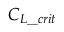Convert formula to latex. <formula><loc_0><loc_0><loc_500><loc_500>C _ { L \_ c r i t }</formula> 